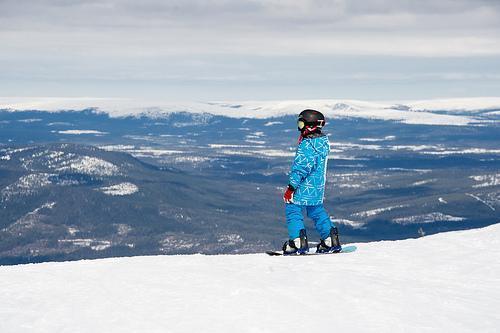How many people are snowboarding?
Give a very brief answer. 1. 